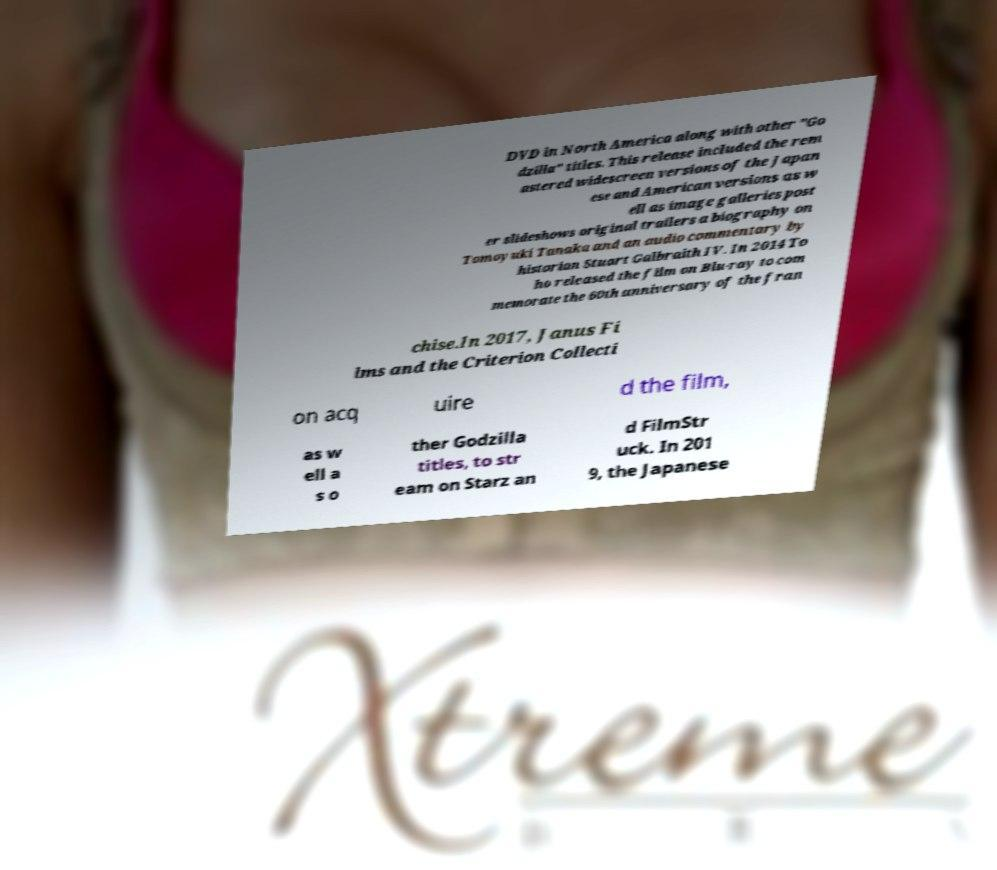Please read and relay the text visible in this image. What does it say? DVD in North America along with other "Go dzilla" titles. This release included the rem astered widescreen versions of the Japan ese and American versions as w ell as image galleries post er slideshows original trailers a biography on Tomoyuki Tanaka and an audio commentary by historian Stuart Galbraith IV. In 2014 To ho released the film on Blu-ray to com memorate the 60th anniversary of the fran chise.In 2017, Janus Fi lms and the Criterion Collecti on acq uire d the film, as w ell a s o ther Godzilla titles, to str eam on Starz an d FilmStr uck. In 201 9, the Japanese 